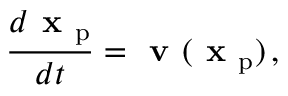<formula> <loc_0><loc_0><loc_500><loc_500>\frac { d x _ { p } } { d t } = v ( x _ { p } ) \, ,</formula> 